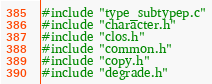Convert code to text. <code><loc_0><loc_0><loc_500><loc_500><_C_>#include "type_subtypep.c"
#include "character.h"
#include "clos.h"
#include "common.h"
#include "copy.h"
#include "degrade.h"</code> 